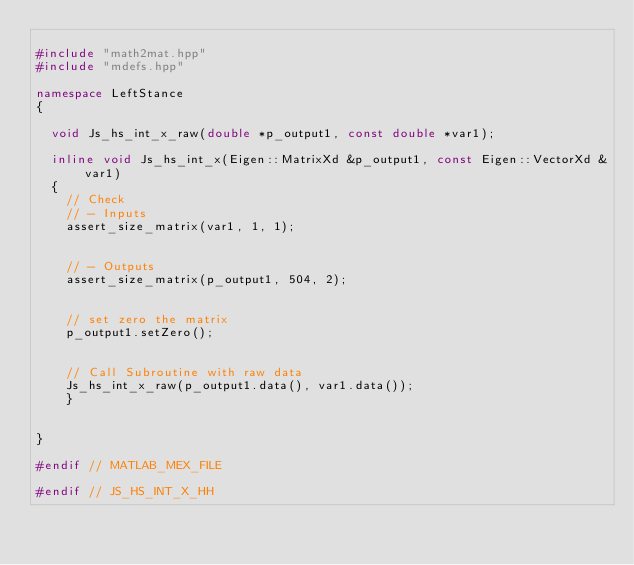<code> <loc_0><loc_0><loc_500><loc_500><_C++_>
#include "math2mat.hpp"
#include "mdefs.hpp"

namespace LeftStance
{

  void Js_hs_int_x_raw(double *p_output1, const double *var1);

  inline void Js_hs_int_x(Eigen::MatrixXd &p_output1, const Eigen::VectorXd &var1)
  {
    // Check
    // - Inputs
    assert_size_matrix(var1, 1, 1);

	
    // - Outputs
    assert_size_matrix(p_output1, 504, 2);


    // set zero the matrix
    p_output1.setZero();


    // Call Subroutine with raw data
    Js_hs_int_x_raw(p_output1.data(), var1.data());
    }
  
  
}

#endif // MATLAB_MEX_FILE

#endif // JS_HS_INT_X_HH
</code> 